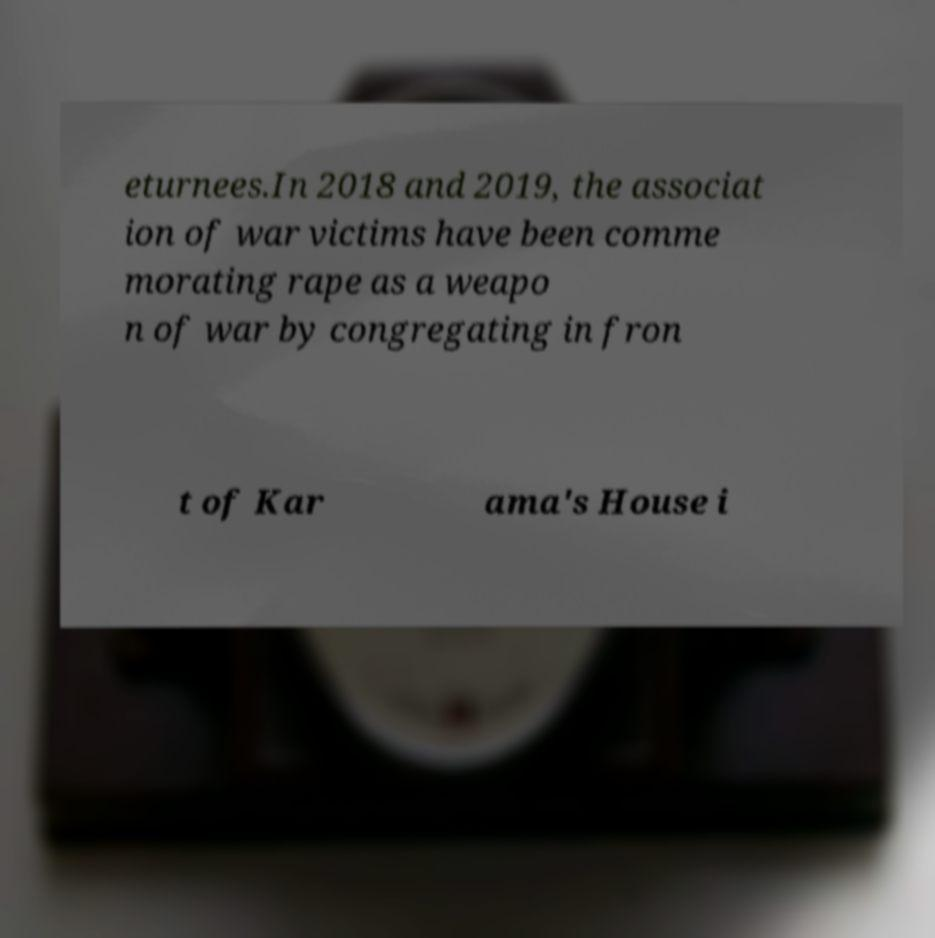Can you accurately transcribe the text from the provided image for me? eturnees.In 2018 and 2019, the associat ion of war victims have been comme morating rape as a weapo n of war by congregating in fron t of Kar ama's House i 